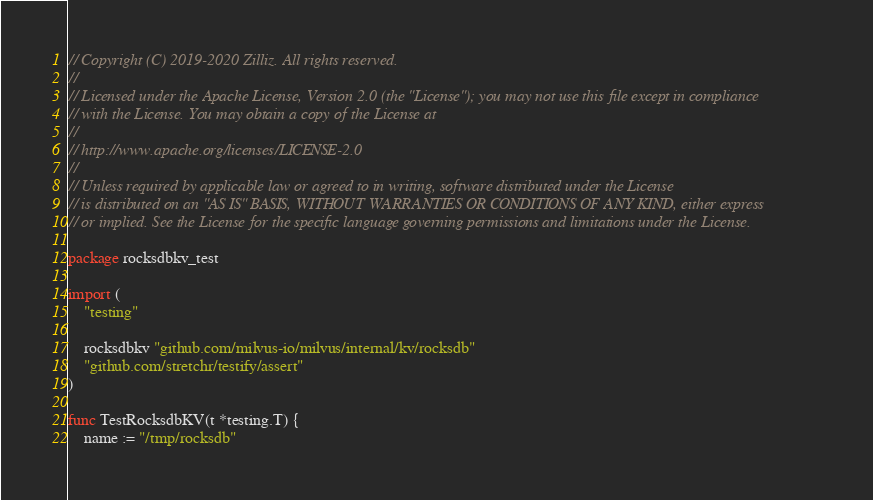<code> <loc_0><loc_0><loc_500><loc_500><_Go_>// Copyright (C) 2019-2020 Zilliz. All rights reserved.
//
// Licensed under the Apache License, Version 2.0 (the "License"); you may not use this file except in compliance
// with the License. You may obtain a copy of the License at
//
// http://www.apache.org/licenses/LICENSE-2.0
//
// Unless required by applicable law or agreed to in writing, software distributed under the License
// is distributed on an "AS IS" BASIS, WITHOUT WARRANTIES OR CONDITIONS OF ANY KIND, either express
// or implied. See the License for the specific language governing permissions and limitations under the License.

package rocksdbkv_test

import (
	"testing"

	rocksdbkv "github.com/milvus-io/milvus/internal/kv/rocksdb"
	"github.com/stretchr/testify/assert"
)

func TestRocksdbKV(t *testing.T) {
	name := "/tmp/rocksdb"</code> 